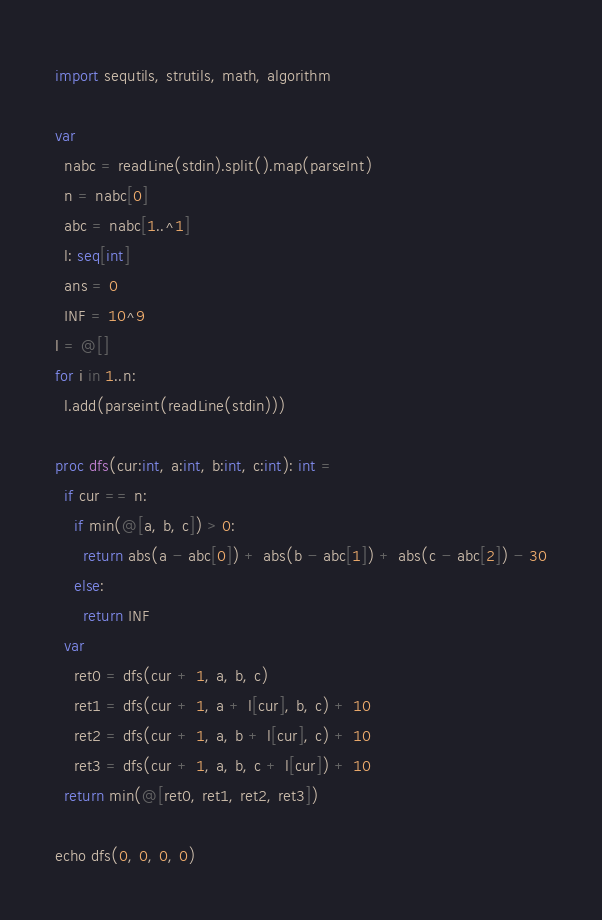<code> <loc_0><loc_0><loc_500><loc_500><_Nim_>import sequtils, strutils, math, algorithm

var
  nabc = readLine(stdin).split().map(parseInt)
  n = nabc[0]
  abc = nabc[1..^1]
  l: seq[int]
  ans = 0
  INF = 10^9
l = @[]
for i in 1..n:
  l.add(parseint(readLine(stdin)))

proc dfs(cur:int, a:int, b:int, c:int): int =
  if cur == n:
    if min(@[a, b, c]) > 0:
      return abs(a - abc[0]) + abs(b - abc[1]) + abs(c - abc[2]) - 30
    else:
      return INF
  var
    ret0 = dfs(cur + 1, a, b, c)
    ret1 = dfs(cur + 1, a + l[cur], b, c) + 10
    ret2 = dfs(cur + 1, a, b + l[cur], c) + 10
    ret3 = dfs(cur + 1, a, b, c + l[cur]) + 10
  return min(@[ret0, ret1, ret2, ret3])

echo dfs(0, 0, 0, 0)</code> 